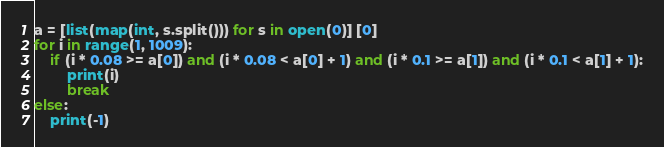<code> <loc_0><loc_0><loc_500><loc_500><_Python_>a = [list(map(int, s.split())) for s in open(0)] [0]
for i in range(1, 1009):
    if (i * 0.08 >= a[0]) and (i * 0.08 < a[0] + 1) and (i * 0.1 >= a[1]) and (i * 0.1 < a[1] + 1):
        print(i)
        break
else:
    print(-1)</code> 